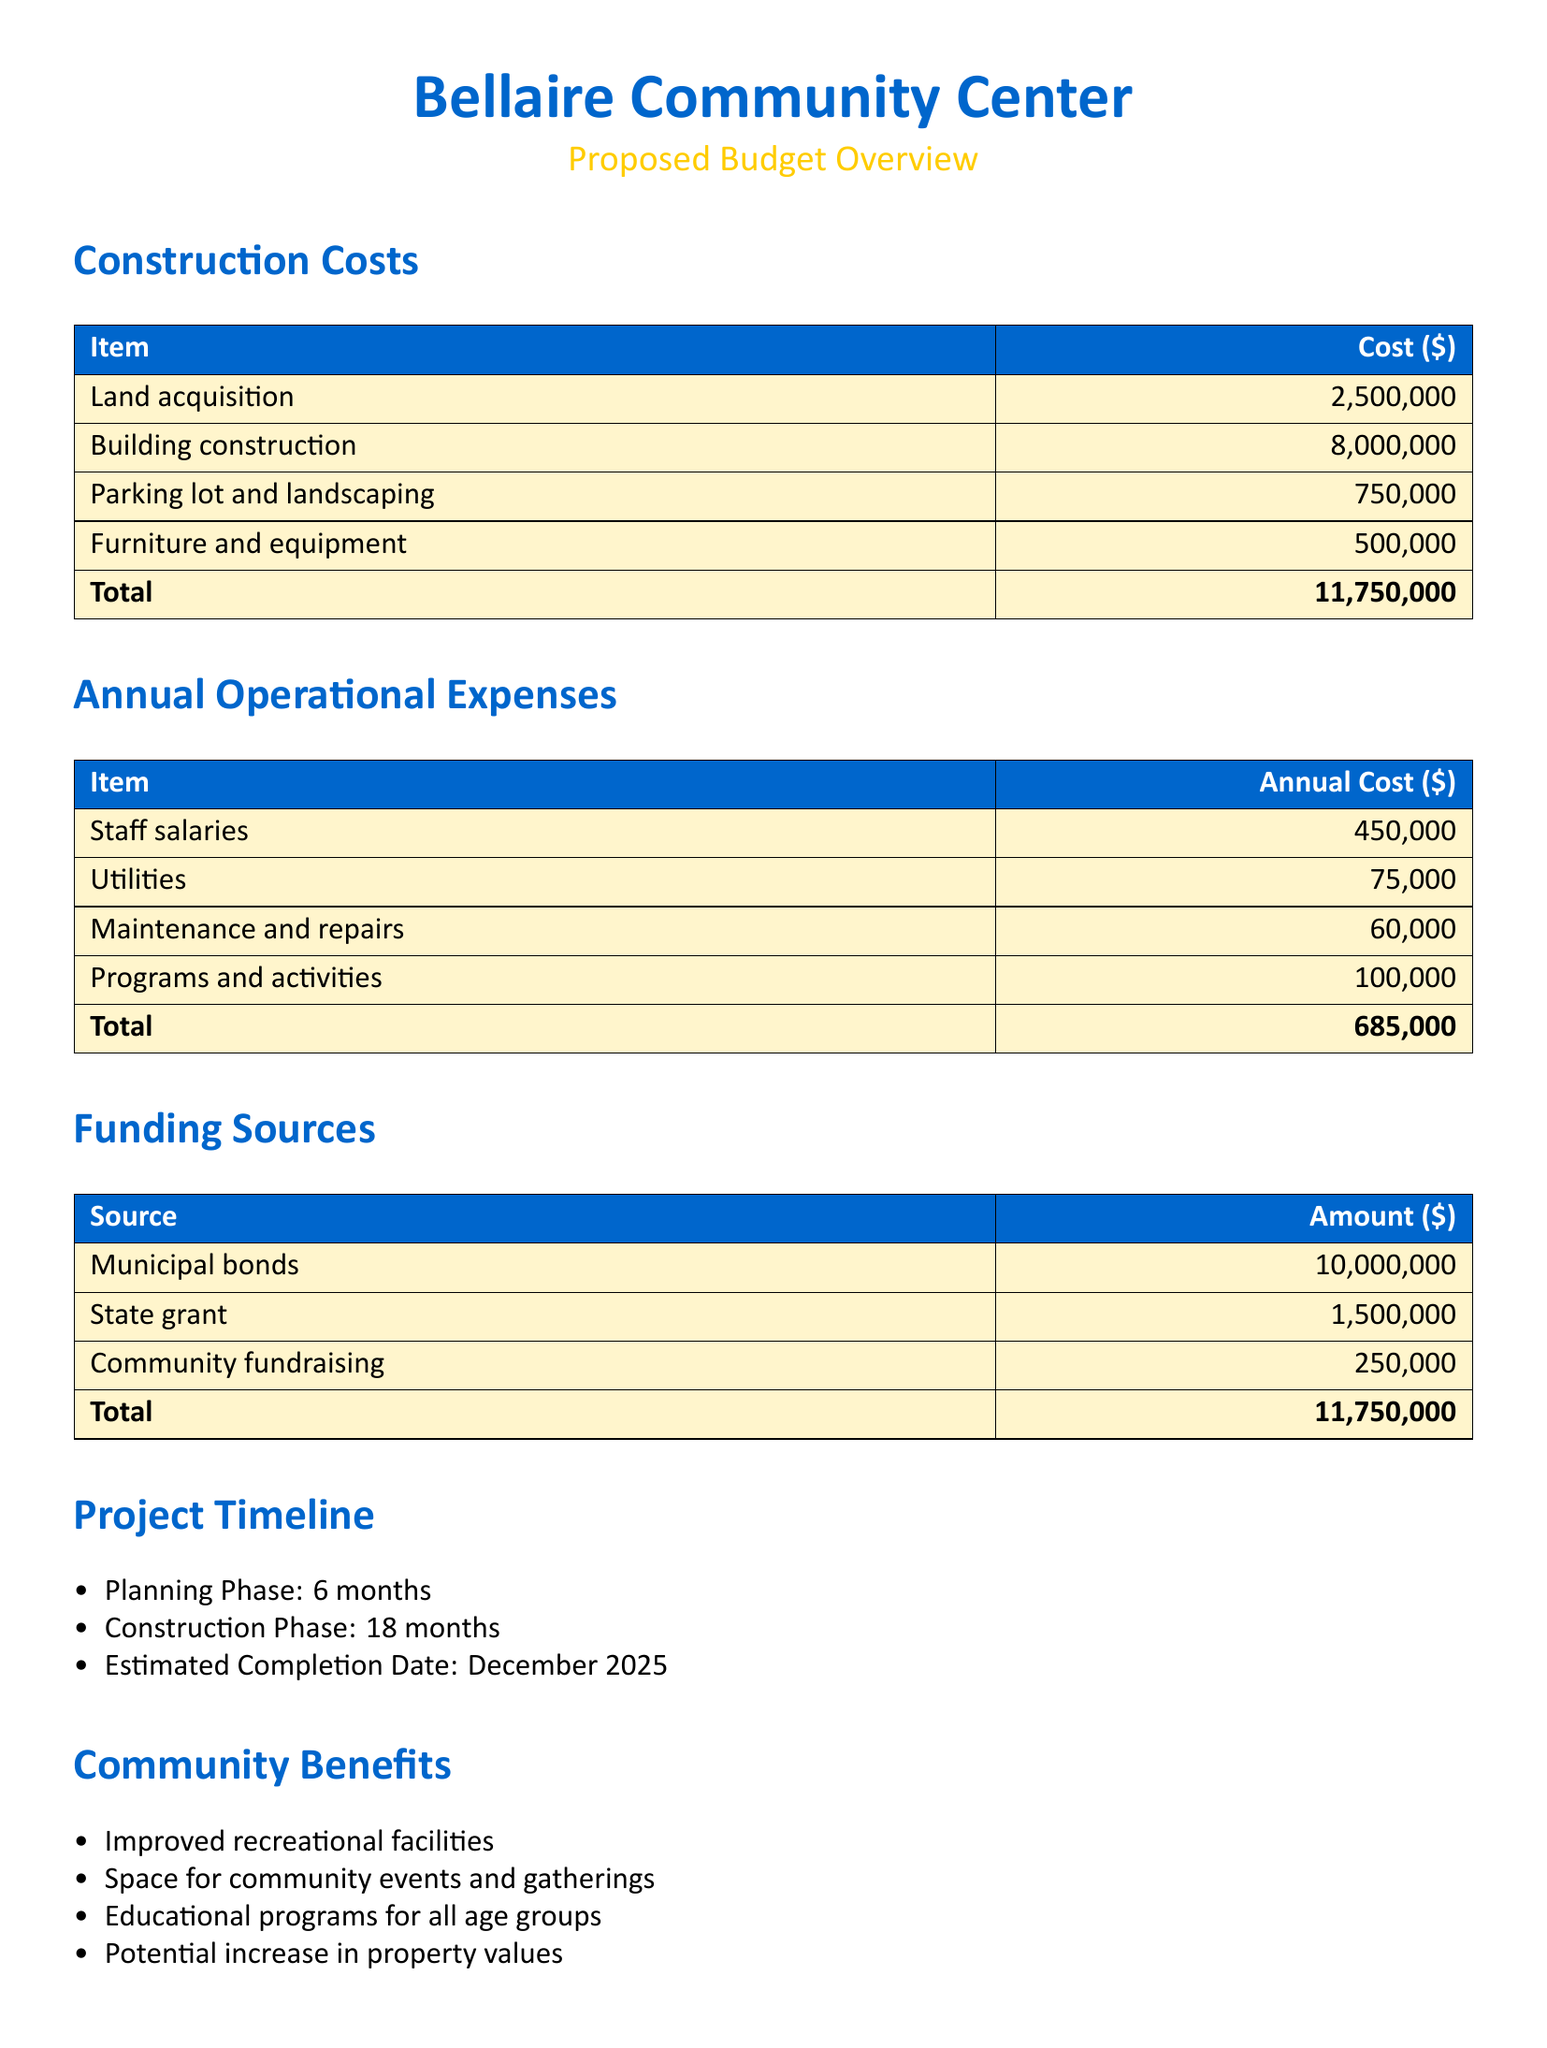What is the total construction cost? The total construction cost is the sum of all construction-related expenses outlined in the document, which is $2,500,000 + $8,000,000 + $750,000 + $500,000 = $11,750,000.
Answer: $11,750,000 What is the annual cost for staff salaries? The annual cost for staff salaries is explicitly stated in the annual operational expenses section of the document.
Answer: $450,000 What funding source contributes the most? The funding source contributing the most can be identified from the funding sources section, which lists municipal bonds as the highest amount.
Answer: Municipal bonds When is the estimated completion date for the project? The estimated completion date is provided in the project timeline section of the document.
Answer: December 2025 What is the cost for utilities annually? The annual cost for utilities is specifically mentioned in the operational expenses table.
Answer: $75,000 What are the total annual operational expenses? The total annual operational expenses are calculated as the sum of all operational costs detailed in the document, which total to $685,000.
Answer: $685,000 How long is the construction phase planned to last? The duration of the construction phase is listed in the project timeline section.
Answer: 18 months What is the total amount of state grant funding? The total amount of state grant funding is clearly stated in the funding sources section of the document.
Answer: $1,500,000 What benefit involves increased property values? The community benefit related to property values is mentioned in the community benefits section of the document.
Answer: Potential increase in property values 